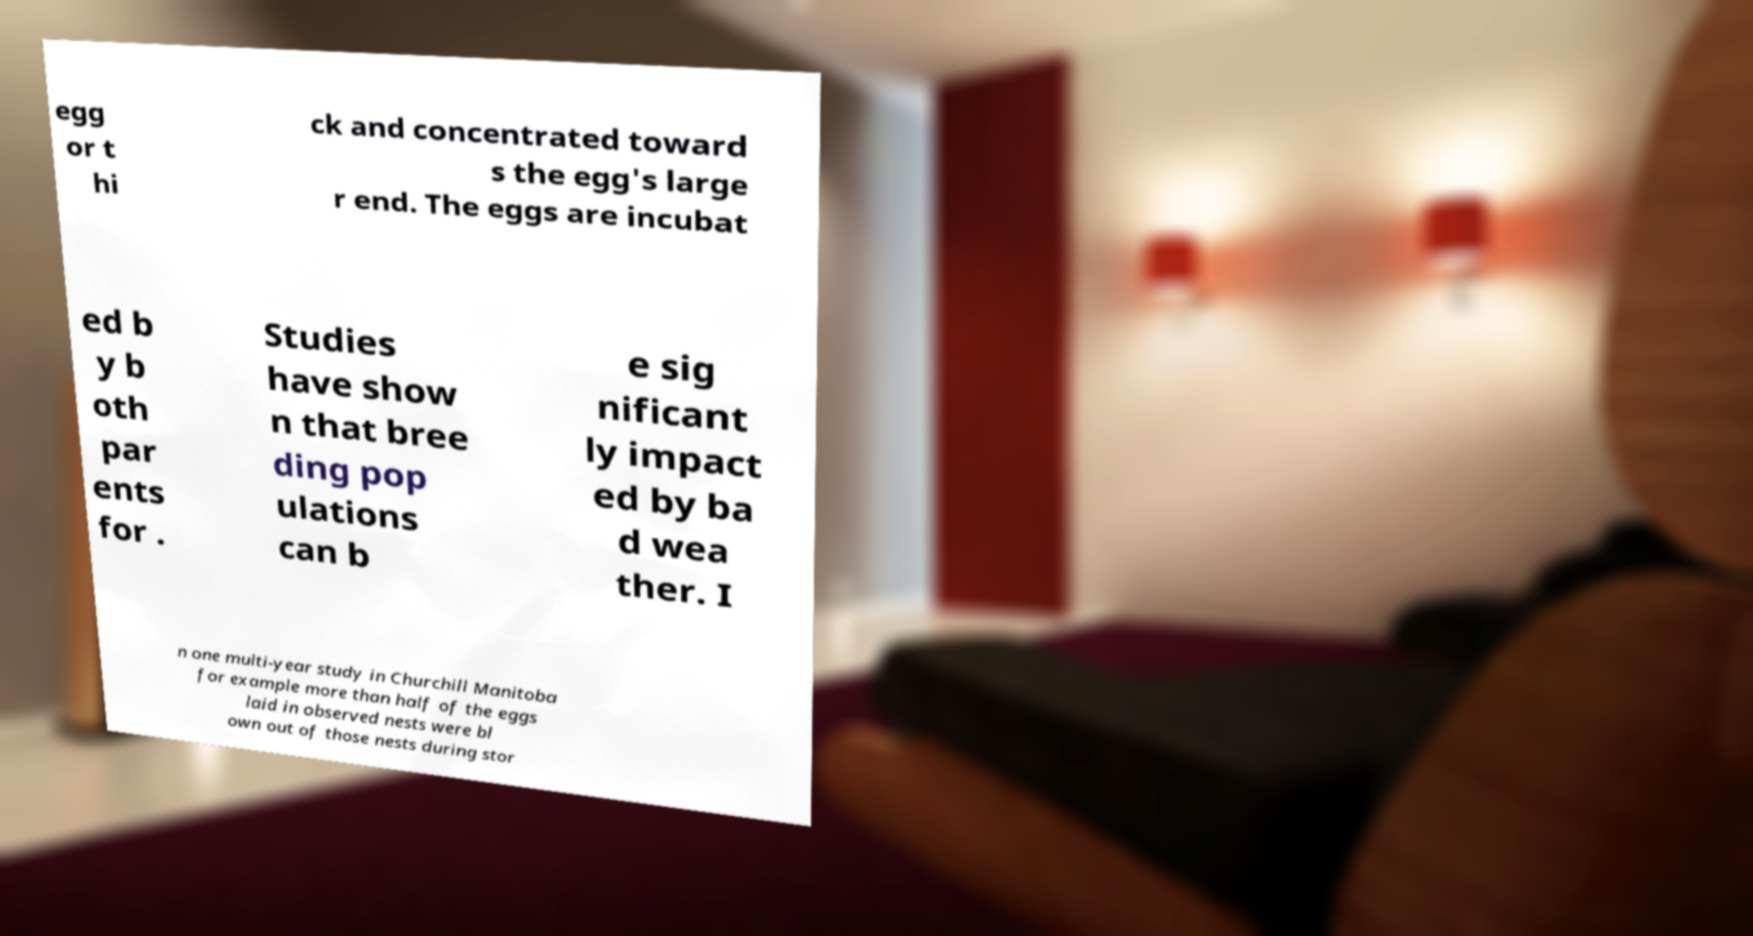For documentation purposes, I need the text within this image transcribed. Could you provide that? egg or t hi ck and concentrated toward s the egg's large r end. The eggs are incubat ed b y b oth par ents for . Studies have show n that bree ding pop ulations can b e sig nificant ly impact ed by ba d wea ther. I n one multi-year study in Churchill Manitoba for example more than half of the eggs laid in observed nests were bl own out of those nests during stor 